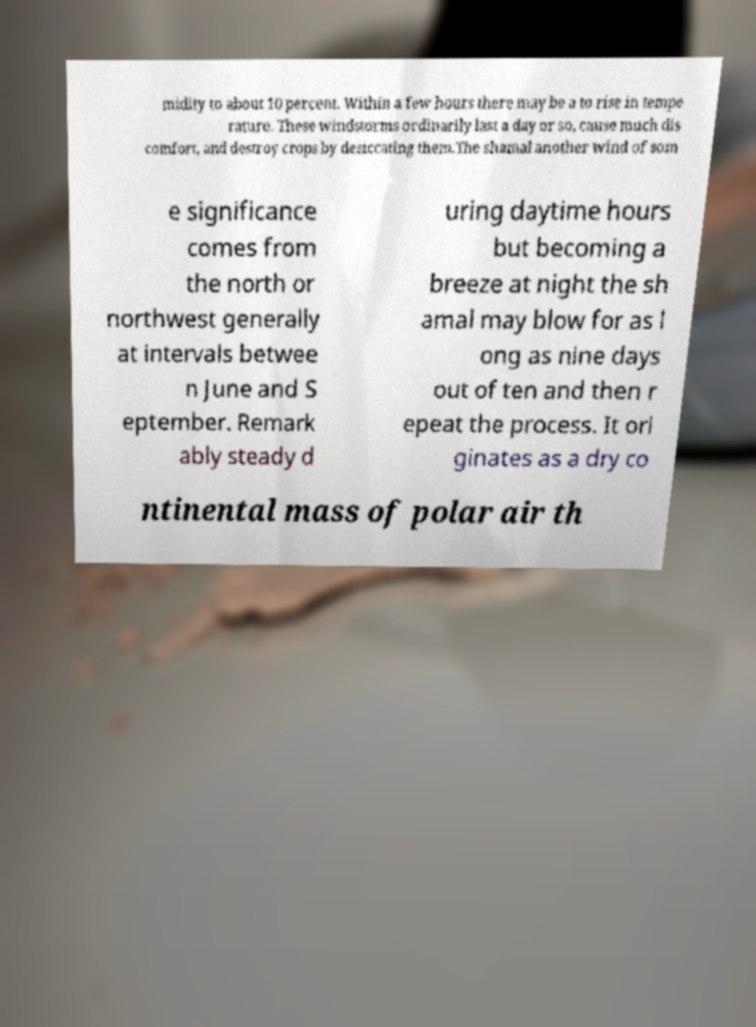There's text embedded in this image that I need extracted. Can you transcribe it verbatim? midity to about 10 percent. Within a few hours there may be a to rise in tempe rature. These windstorms ordinarily last a day or so, cause much dis comfort, and destroy crops by desiccating them.The shamal another wind of som e significance comes from the north or northwest generally at intervals betwee n June and S eptember. Remark ably steady d uring daytime hours but becoming a breeze at night the sh amal may blow for as l ong as nine days out of ten and then r epeat the process. It ori ginates as a dry co ntinental mass of polar air th 